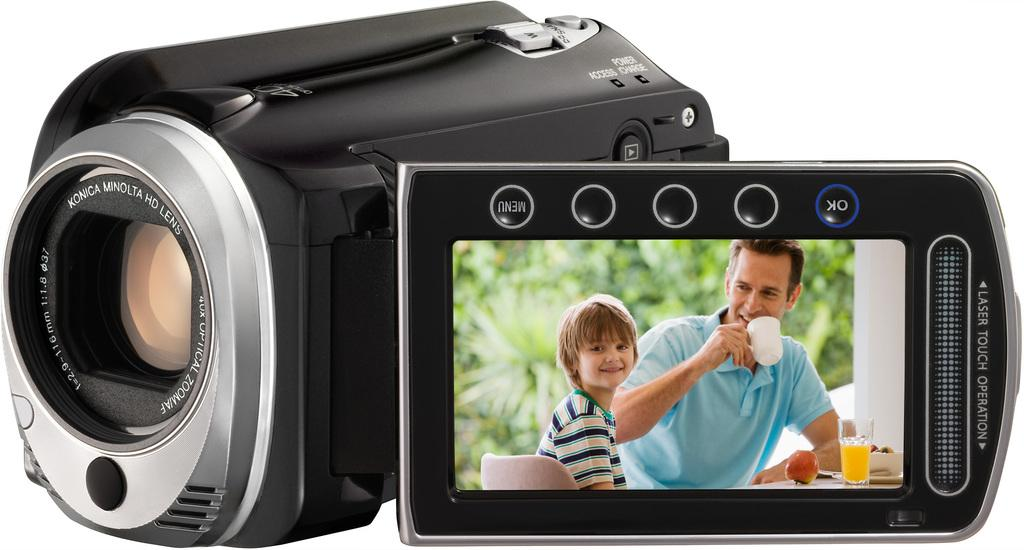What is the main object in the image? There is a camcorder in the image. What can be seen on the camcorder? The camcorder has a photo of two smiling persons. What is the color of the background in the image? The background of the image is white. What type of oatmeal is being served in the image? There is no oatmeal present in the image. What is the position of the cent in the image? There is no cent present in the image. 